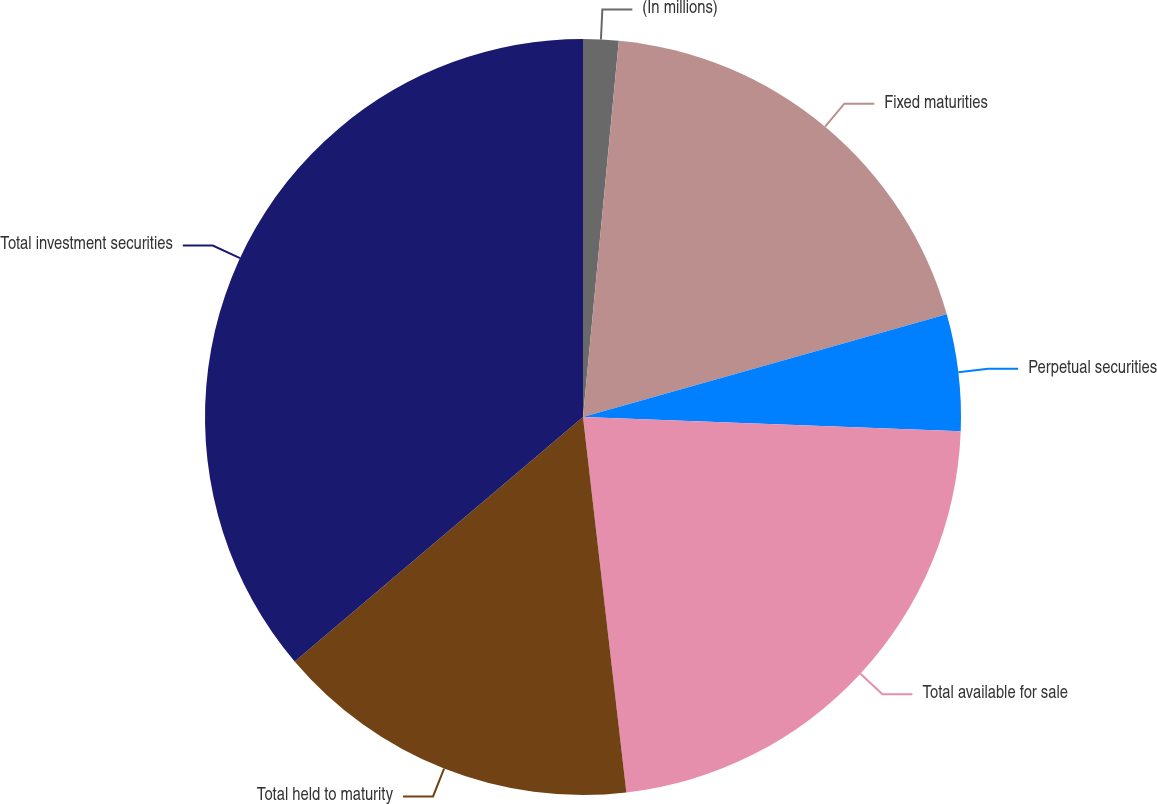Convert chart to OTSL. <chart><loc_0><loc_0><loc_500><loc_500><pie_chart><fcel>(In millions)<fcel>Fixed maturities<fcel>Perpetual securities<fcel>Total available for sale<fcel>Total held to maturity<fcel>Total investment securities<nl><fcel>1.51%<fcel>19.11%<fcel>4.98%<fcel>22.57%<fcel>15.64%<fcel>36.19%<nl></chart> 